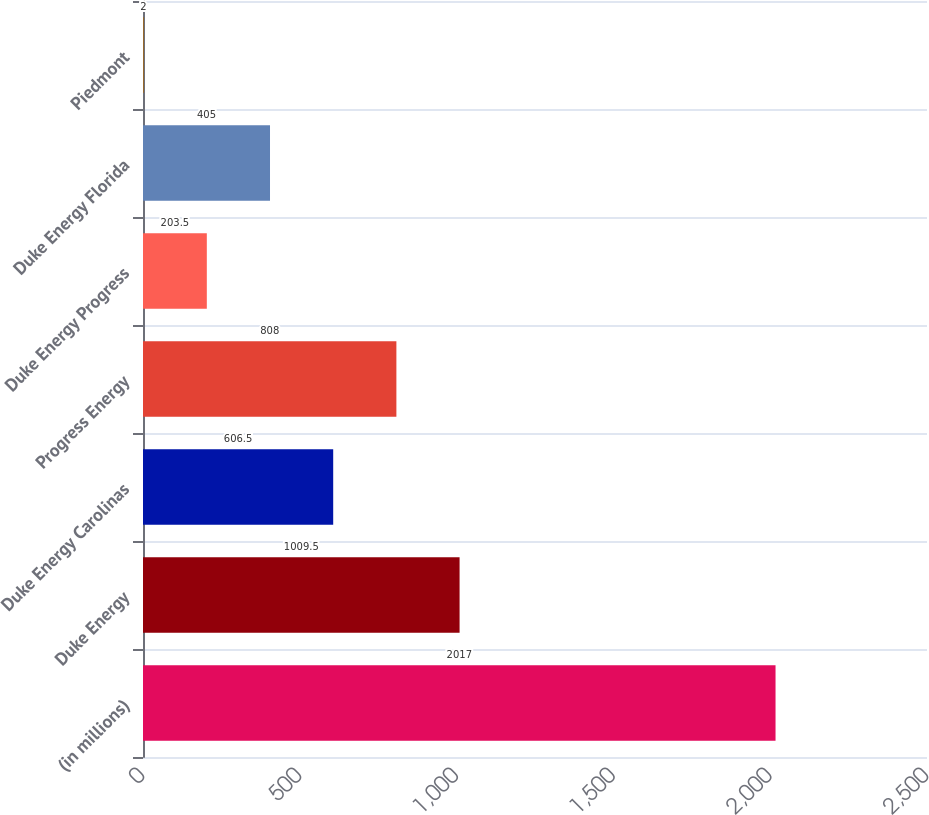Convert chart. <chart><loc_0><loc_0><loc_500><loc_500><bar_chart><fcel>(in millions)<fcel>Duke Energy<fcel>Duke Energy Carolinas<fcel>Progress Energy<fcel>Duke Energy Progress<fcel>Duke Energy Florida<fcel>Piedmont<nl><fcel>2017<fcel>1009.5<fcel>606.5<fcel>808<fcel>203.5<fcel>405<fcel>2<nl></chart> 